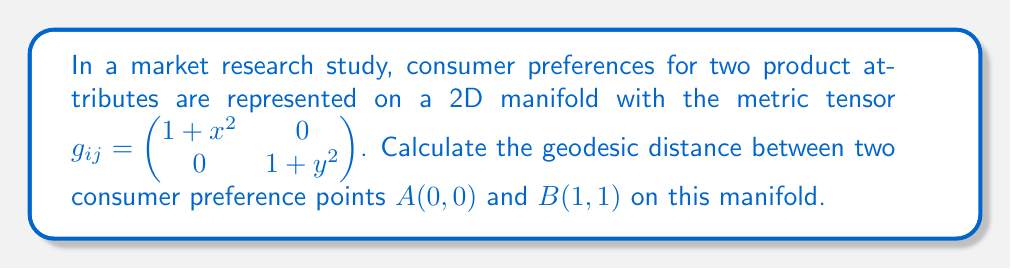What is the answer to this math problem? To calculate the geodesic distance between two points on a manifold, we need to solve the geodesic equation and then compute the length of the geodesic curve. However, for this specific metric tensor, we can use a simpler approach:

1) The geodesic equation for this metric tensor results in straight lines in the $(x,y)$ coordinate system.

2) The arc length of a curve $\gamma(t) = (x(t), y(t))$ from $t=0$ to $t=1$ is given by:

   $$s = \int_0^1 \sqrt{g_{ij}\frac{dx^i}{dt}\frac{dx^j}{dt}}dt$$

3) For a straight line from $(0,0)$ to $(1,1)$, we have $x(t) = t$ and $y(t) = t$. Therefore:

   $$\frac{dx}{dt} = 1, \frac{dy}{dt} = 1$$

4) Substituting into the arc length formula:

   $$s = \int_0^1 \sqrt{(1+t^2)(1)^2 + (1+t^2)(1)^2}dt$$

5) Simplifying:

   $$s = \int_0^1 \sqrt{2(1+t^2)}dt = \sqrt{2}\int_0^1 \sqrt{1+t^2}dt$$

6) This integral can be solved using the substitution $t = \tan\theta$:

   $$s = \sqrt{2}[\ln(t + \sqrt{1+t^2})]_0^1$$

7) Evaluating the limits:

   $$s = \sqrt{2}[\ln(1 + \sqrt{2}) - \ln(1)] = \sqrt{2}\ln(1 + \sqrt{2})$$

This is the geodesic distance between the two consumer preference points on the given manifold.
Answer: $\sqrt{2}\ln(1 + \sqrt{2})$ 